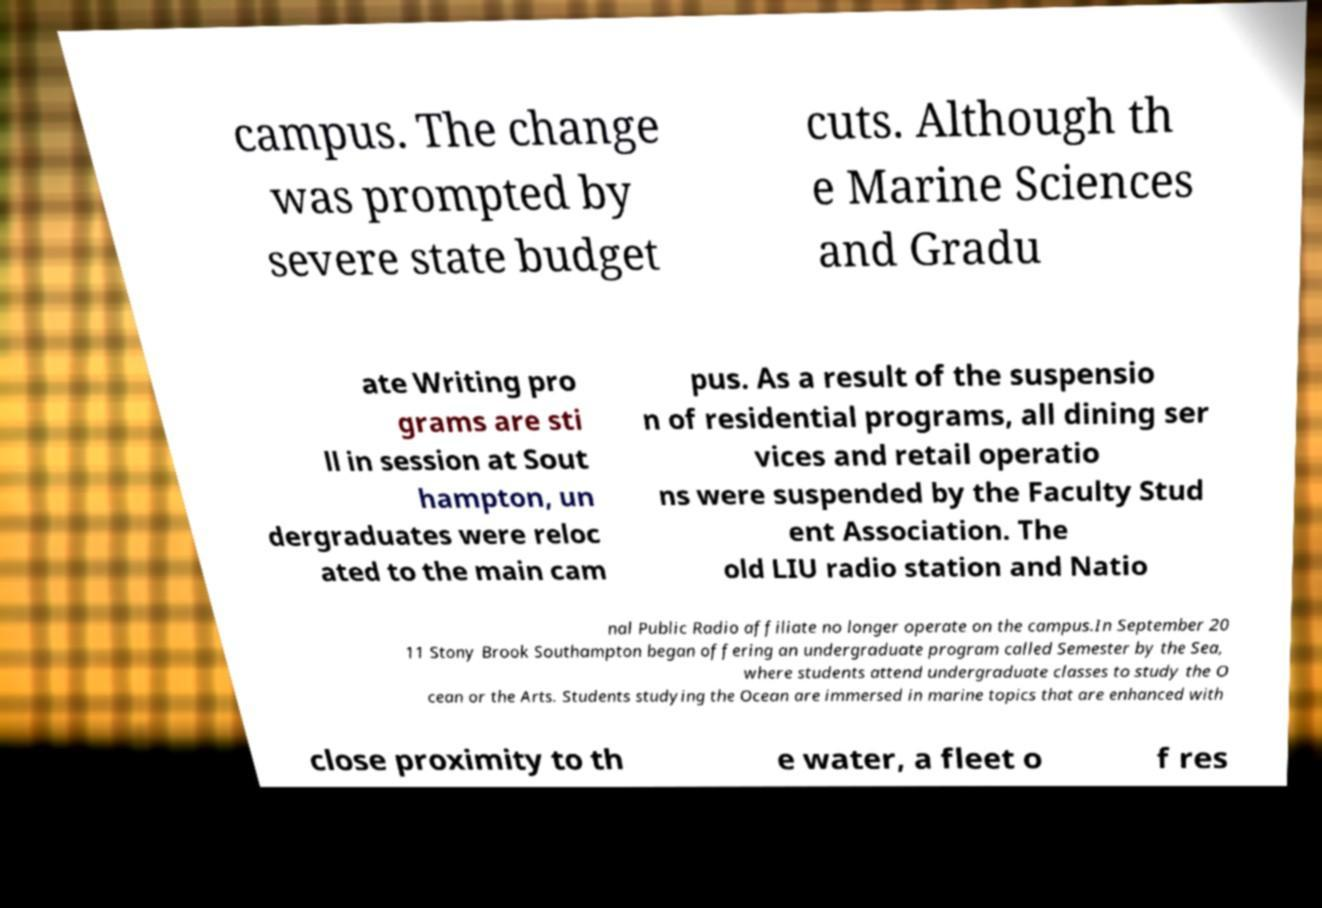Could you extract and type out the text from this image? campus. The change was prompted by severe state budget cuts. Although th e Marine Sciences and Gradu ate Writing pro grams are sti ll in session at Sout hampton, un dergraduates were reloc ated to the main cam pus. As a result of the suspensio n of residential programs, all dining ser vices and retail operatio ns were suspended by the Faculty Stud ent Association. The old LIU radio station and Natio nal Public Radio affiliate no longer operate on the campus.In September 20 11 Stony Brook Southampton began offering an undergraduate program called Semester by the Sea, where students attend undergraduate classes to study the O cean or the Arts. Students studying the Ocean are immersed in marine topics that are enhanced with close proximity to th e water, a fleet o f res 